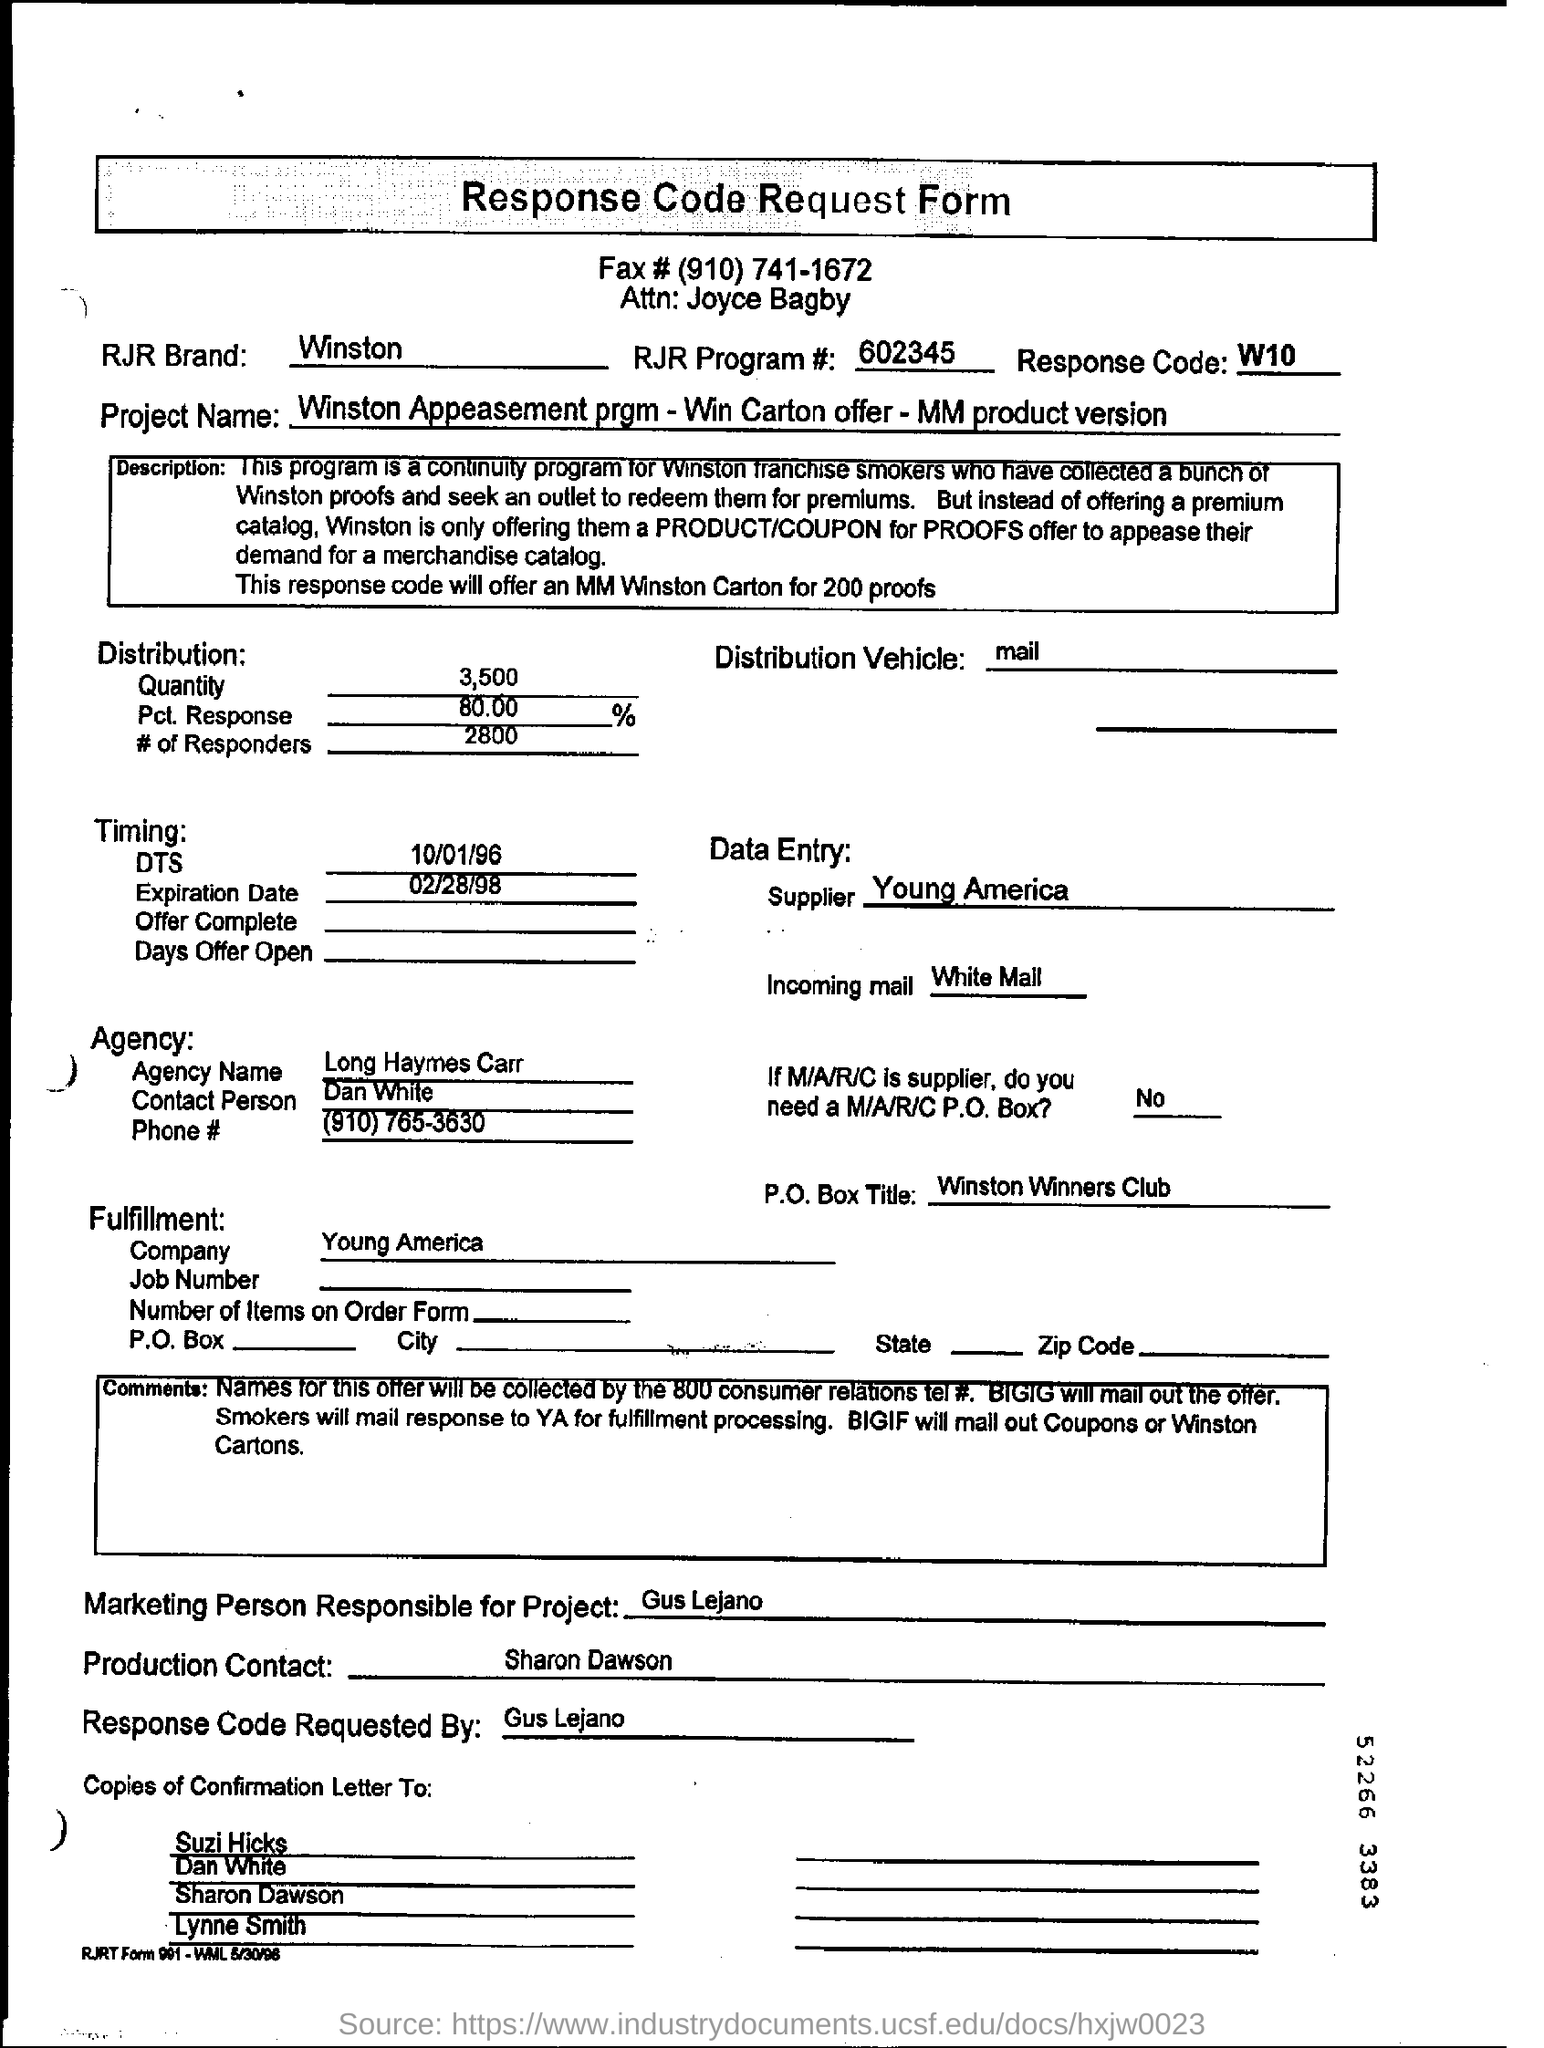Draw attention to some important aspects in this diagram. The Winston Appeasement Program, also known as Win Carton Offer and MM Product Version, is a project whose name is unknown. The name of the agency is Long Haymes Carr. 